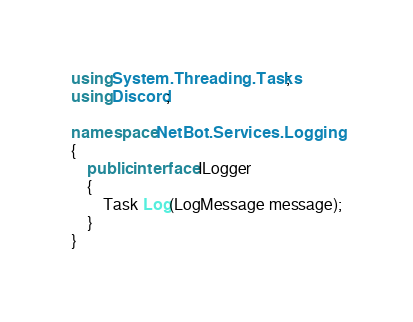Convert code to text. <code><loc_0><loc_0><loc_500><loc_500><_C#_>using System.Threading.Tasks;
using Discord;

namespace NetBot.Services.Logging
{
    public interface ILogger
    {
        Task Log(LogMessage message);
    }
}</code> 